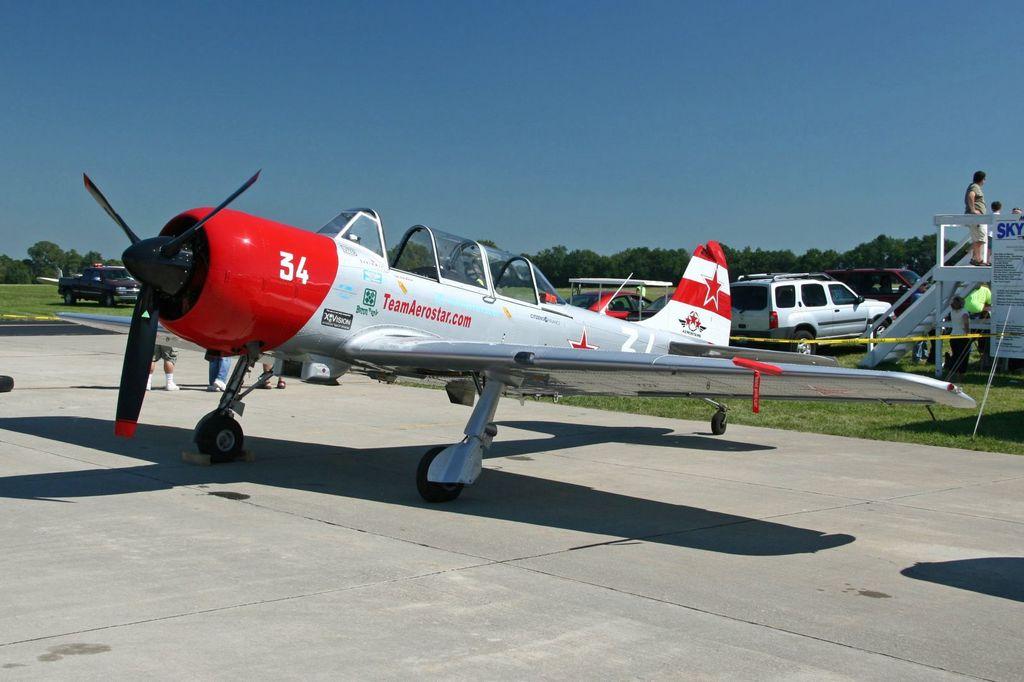What is the word on the side of this plane?
Keep it short and to the point. Teamaerostar.com. What number is this plane?
Offer a terse response. 34. 